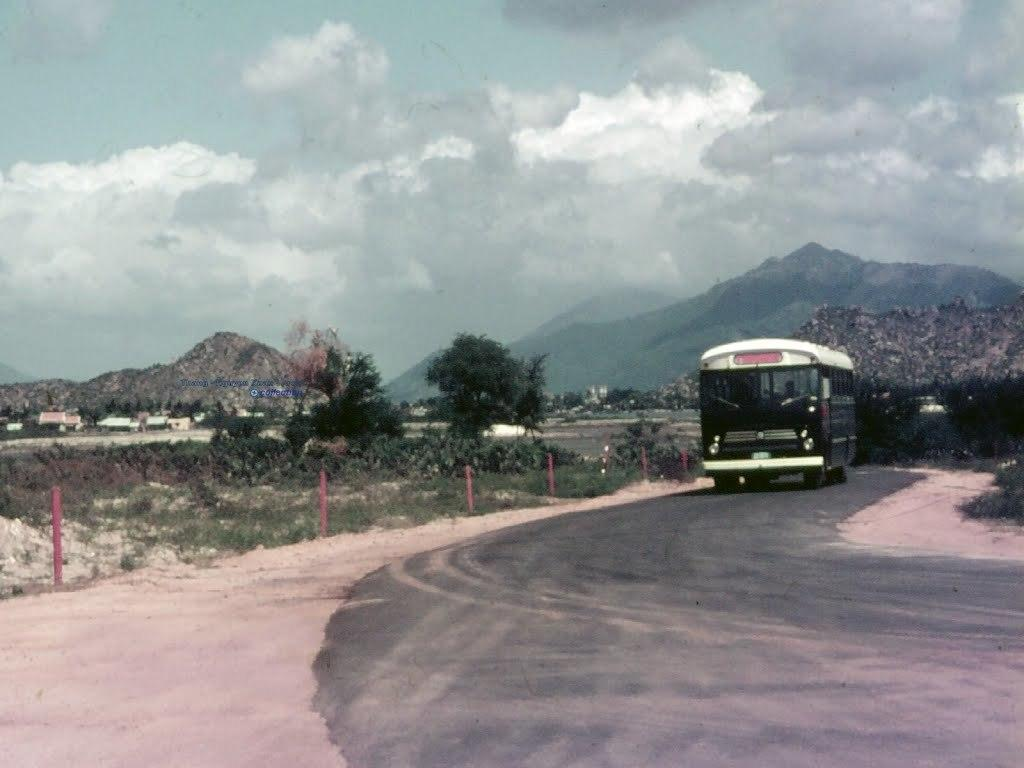What is the main subject of the image? There is a bus in the image. Where is the bus located? The bus is on the road. What can be seen in the background of the image? There are poles, trees, mountains, and the sky visible in the background of the image. What type of mark can be seen on the bus in the image? There is no mark visible on the bus in the image. What is the bus using to write on the road? The bus is not writing on the road, and there is no pen present in the image. 